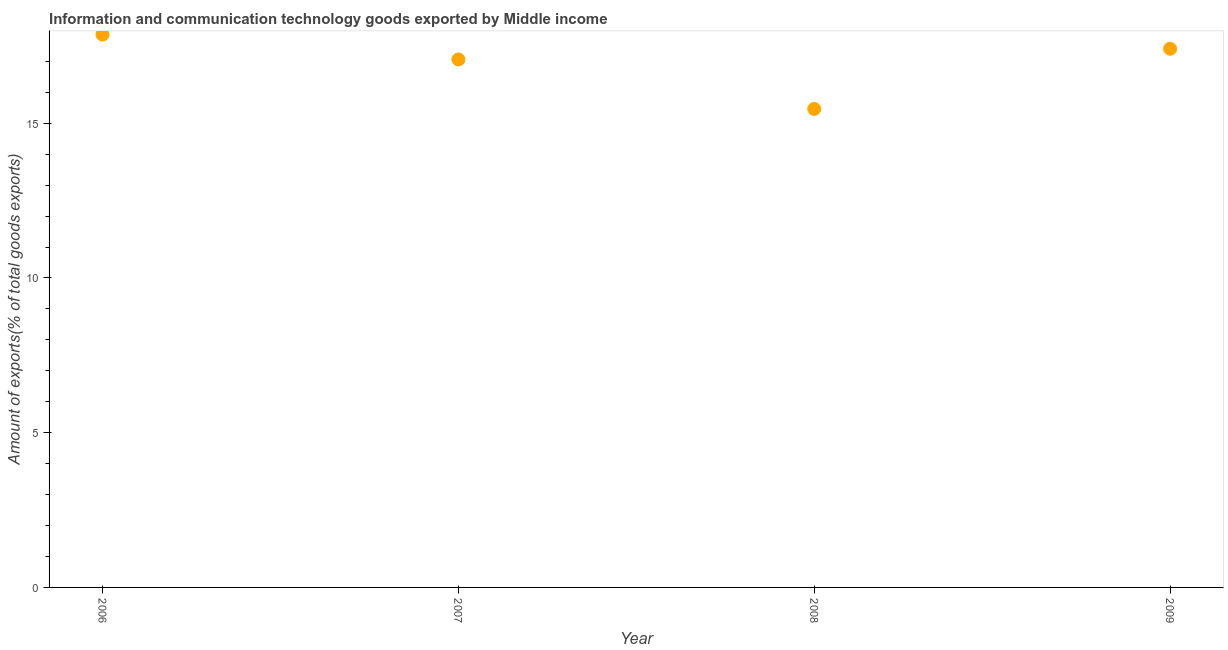What is the amount of ict goods exports in 2007?
Your answer should be very brief. 17.06. Across all years, what is the maximum amount of ict goods exports?
Provide a short and direct response. 17.86. Across all years, what is the minimum amount of ict goods exports?
Keep it short and to the point. 15.46. In which year was the amount of ict goods exports maximum?
Ensure brevity in your answer.  2006. What is the sum of the amount of ict goods exports?
Offer a terse response. 67.79. What is the difference between the amount of ict goods exports in 2008 and 2009?
Provide a short and direct response. -1.94. What is the average amount of ict goods exports per year?
Your answer should be compact. 16.95. What is the median amount of ict goods exports?
Keep it short and to the point. 17.23. In how many years, is the amount of ict goods exports greater than 2 %?
Give a very brief answer. 4. Do a majority of the years between 2006 and 2008 (inclusive) have amount of ict goods exports greater than 4 %?
Offer a very short reply. Yes. What is the ratio of the amount of ict goods exports in 2006 to that in 2008?
Give a very brief answer. 1.16. Is the amount of ict goods exports in 2007 less than that in 2009?
Provide a succinct answer. Yes. Is the difference between the amount of ict goods exports in 2006 and 2008 greater than the difference between any two years?
Keep it short and to the point. Yes. What is the difference between the highest and the second highest amount of ict goods exports?
Your response must be concise. 0.46. Is the sum of the amount of ict goods exports in 2006 and 2007 greater than the maximum amount of ict goods exports across all years?
Your response must be concise. Yes. What is the difference between the highest and the lowest amount of ict goods exports?
Offer a terse response. 2.4. Does the amount of ict goods exports monotonically increase over the years?
Ensure brevity in your answer.  No. What is the difference between two consecutive major ticks on the Y-axis?
Offer a terse response. 5. Are the values on the major ticks of Y-axis written in scientific E-notation?
Ensure brevity in your answer.  No. Does the graph contain any zero values?
Provide a short and direct response. No. What is the title of the graph?
Offer a terse response. Information and communication technology goods exported by Middle income. What is the label or title of the X-axis?
Your answer should be very brief. Year. What is the label or title of the Y-axis?
Your answer should be compact. Amount of exports(% of total goods exports). What is the Amount of exports(% of total goods exports) in 2006?
Provide a short and direct response. 17.86. What is the Amount of exports(% of total goods exports) in 2007?
Offer a terse response. 17.06. What is the Amount of exports(% of total goods exports) in 2008?
Ensure brevity in your answer.  15.46. What is the Amount of exports(% of total goods exports) in 2009?
Ensure brevity in your answer.  17.41. What is the difference between the Amount of exports(% of total goods exports) in 2006 and 2007?
Provide a short and direct response. 0.81. What is the difference between the Amount of exports(% of total goods exports) in 2006 and 2008?
Keep it short and to the point. 2.4. What is the difference between the Amount of exports(% of total goods exports) in 2006 and 2009?
Give a very brief answer. 0.46. What is the difference between the Amount of exports(% of total goods exports) in 2007 and 2008?
Your answer should be compact. 1.6. What is the difference between the Amount of exports(% of total goods exports) in 2007 and 2009?
Keep it short and to the point. -0.35. What is the difference between the Amount of exports(% of total goods exports) in 2008 and 2009?
Provide a succinct answer. -1.94. What is the ratio of the Amount of exports(% of total goods exports) in 2006 to that in 2007?
Your answer should be very brief. 1.05. What is the ratio of the Amount of exports(% of total goods exports) in 2006 to that in 2008?
Offer a terse response. 1.16. What is the ratio of the Amount of exports(% of total goods exports) in 2006 to that in 2009?
Provide a short and direct response. 1.03. What is the ratio of the Amount of exports(% of total goods exports) in 2007 to that in 2008?
Ensure brevity in your answer.  1.1. What is the ratio of the Amount of exports(% of total goods exports) in 2008 to that in 2009?
Ensure brevity in your answer.  0.89. 